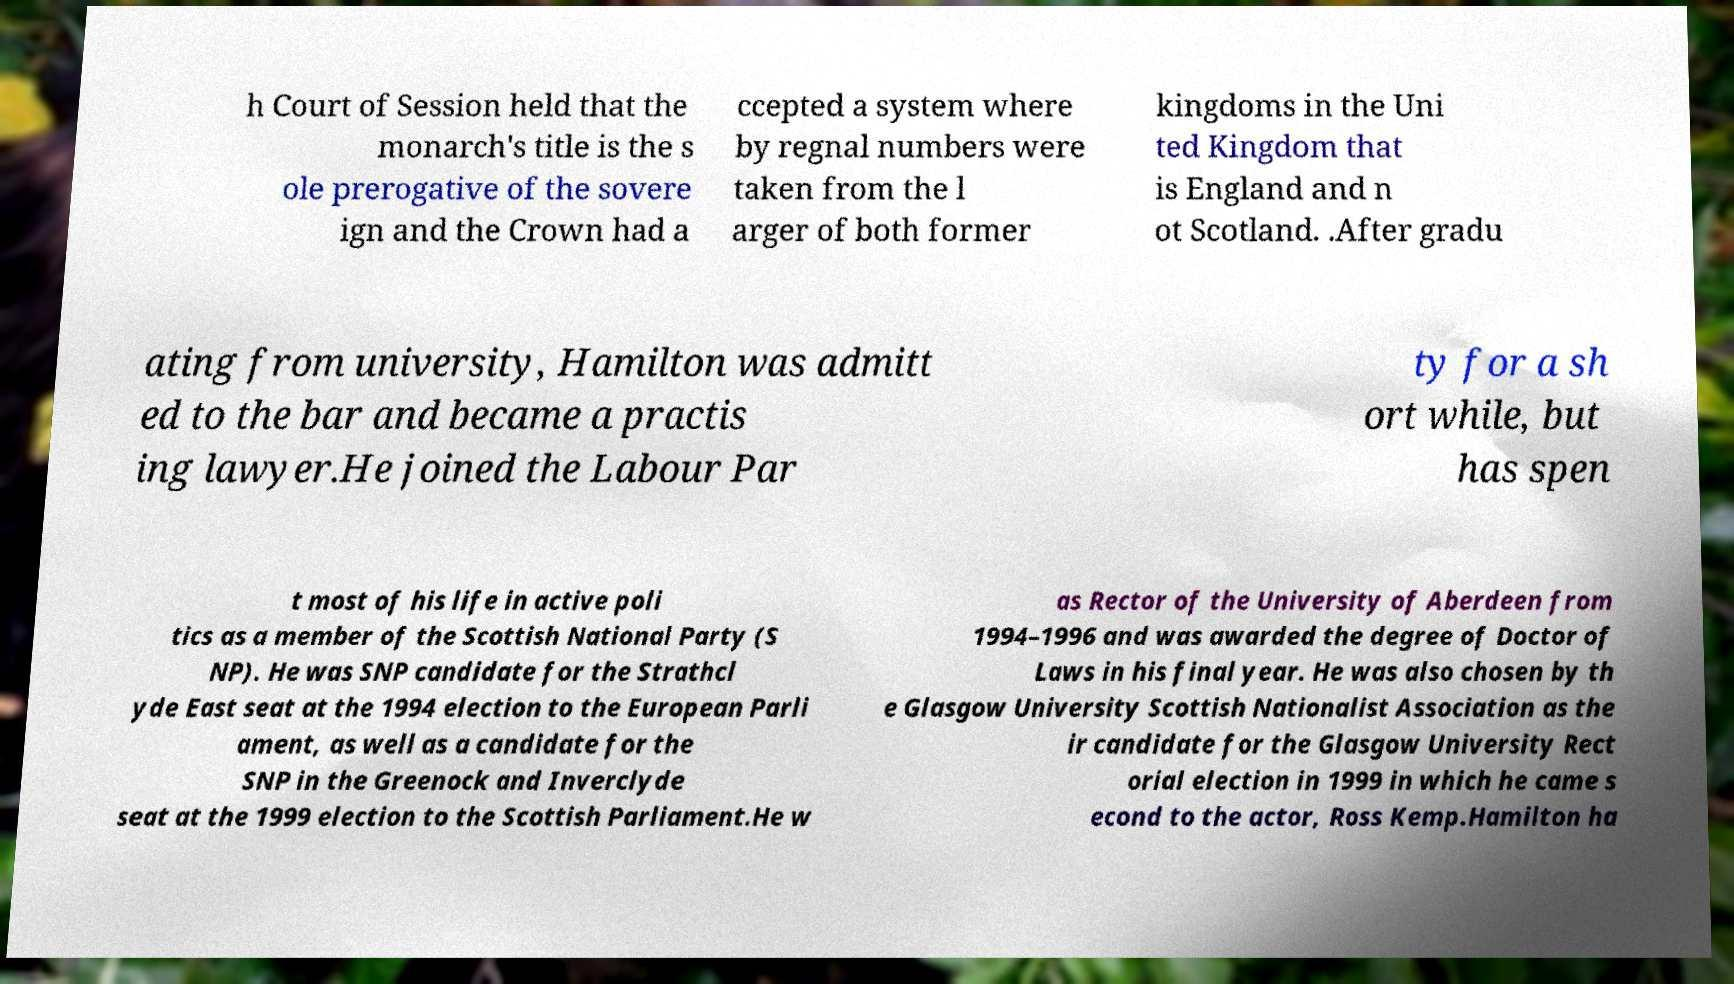Please identify and transcribe the text found in this image. h Court of Session held that the monarch's title is the s ole prerogative of the sovere ign and the Crown had a ccepted a system where by regnal numbers were taken from the l arger of both former kingdoms in the Uni ted Kingdom that is England and n ot Scotland. .After gradu ating from university, Hamilton was admitt ed to the bar and became a practis ing lawyer.He joined the Labour Par ty for a sh ort while, but has spen t most of his life in active poli tics as a member of the Scottish National Party (S NP). He was SNP candidate for the Strathcl yde East seat at the 1994 election to the European Parli ament, as well as a candidate for the SNP in the Greenock and Inverclyde seat at the 1999 election to the Scottish Parliament.He w as Rector of the University of Aberdeen from 1994–1996 and was awarded the degree of Doctor of Laws in his final year. He was also chosen by th e Glasgow University Scottish Nationalist Association as the ir candidate for the Glasgow University Rect orial election in 1999 in which he came s econd to the actor, Ross Kemp.Hamilton ha 